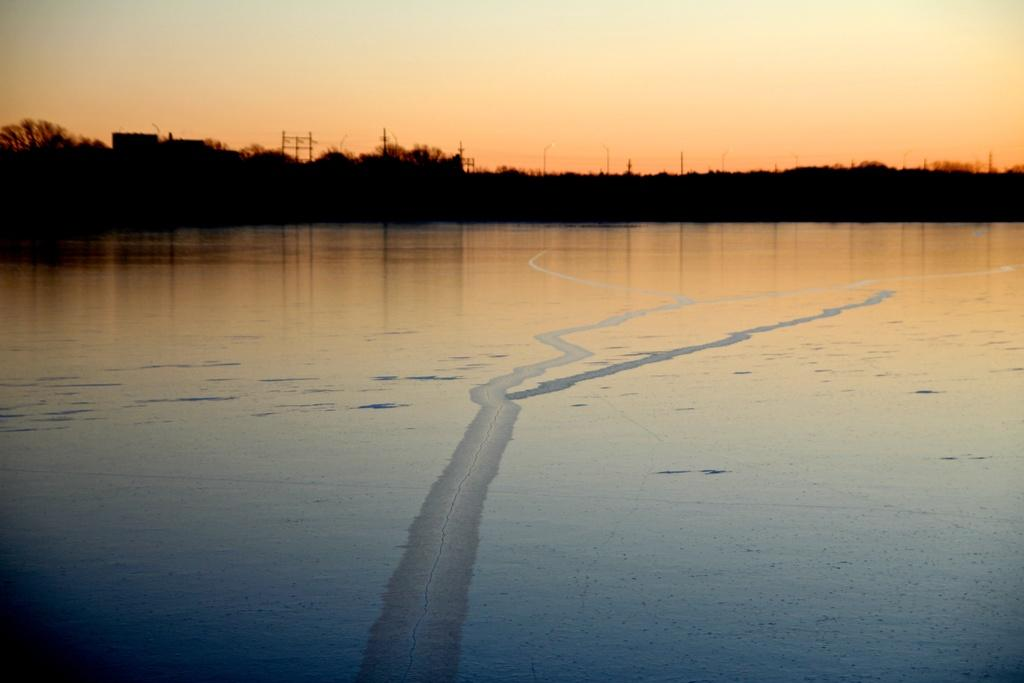What is the primary element in the image? The image consists of water. What can be seen in the background of the image? There are trees in the background of the image. What is visible at the top of the image? The sky is visible at the top of the image. What time of day is it in the image, and what are the police doing? The time of day is not mentioned in the image, and there are no police present. 